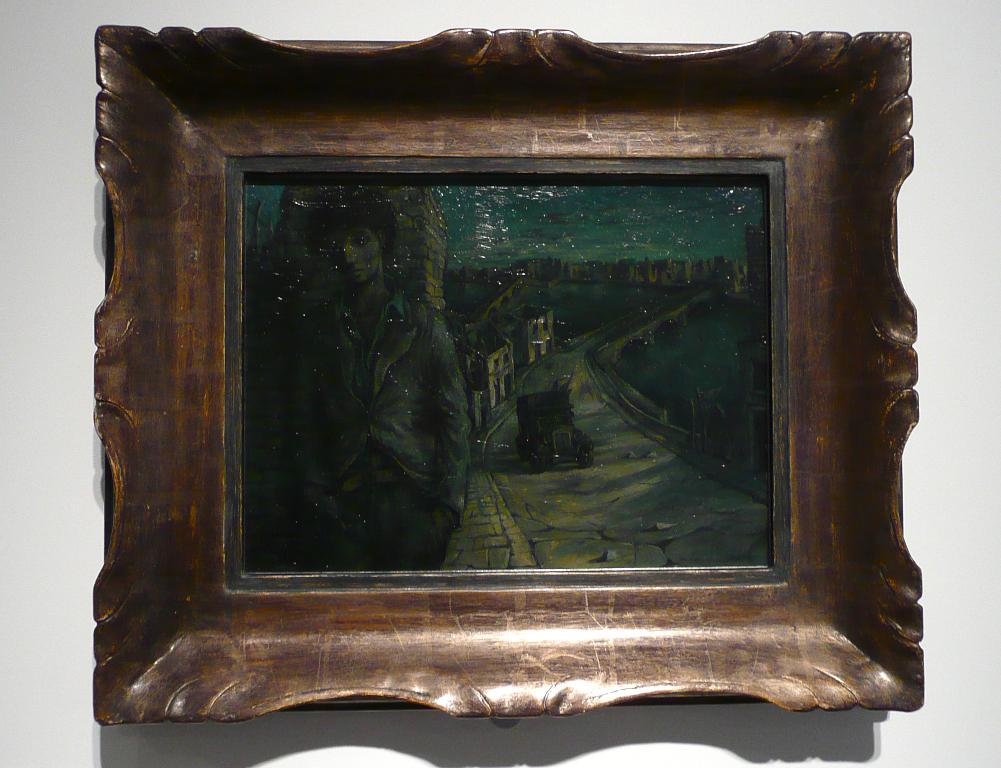What object can be seen in the image? There is a photo frame in the image. Where is the photo frame located? The photo frame is on a wall. What type of agreement is being discussed in the image? There is no discussion or agreement present in the image; it only features a photo frame on a wall. 